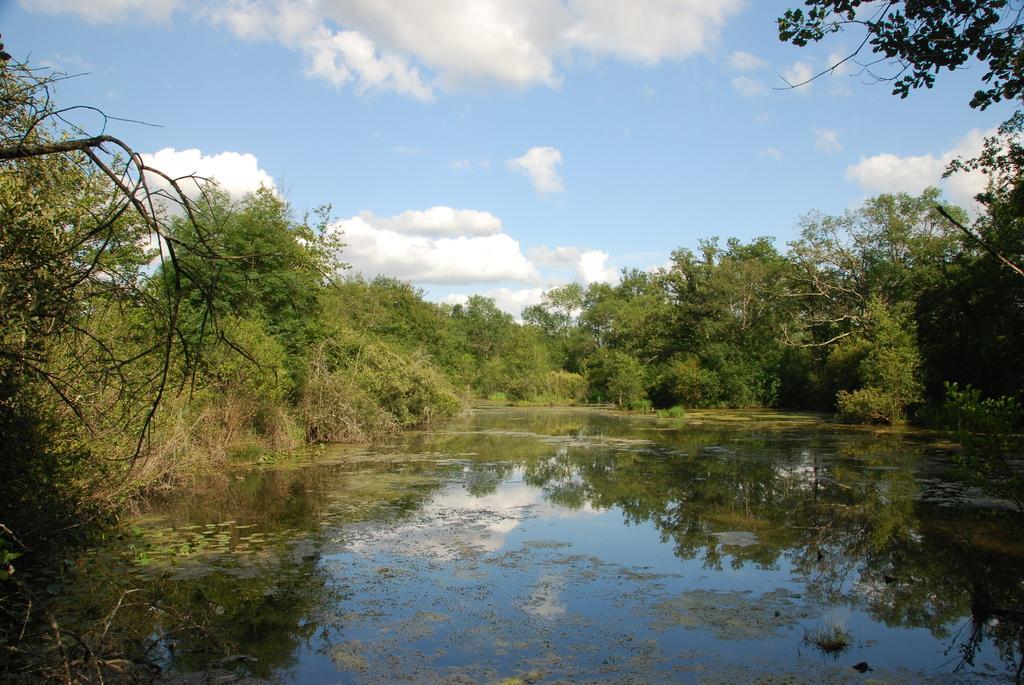How would you summarize this image in a sentence or two? At the bottom of the image there is water. In the background there are trees. At the top of the image there is sky with clouds. 